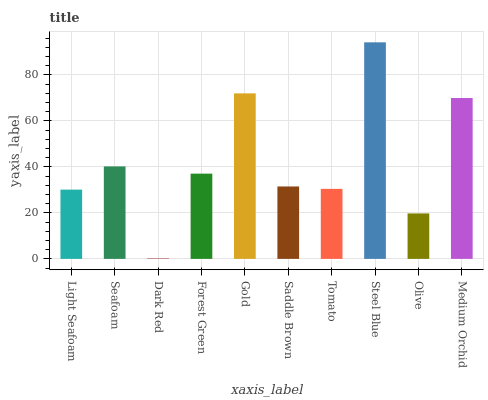Is Dark Red the minimum?
Answer yes or no. Yes. Is Steel Blue the maximum?
Answer yes or no. Yes. Is Seafoam the minimum?
Answer yes or no. No. Is Seafoam the maximum?
Answer yes or no. No. Is Seafoam greater than Light Seafoam?
Answer yes or no. Yes. Is Light Seafoam less than Seafoam?
Answer yes or no. Yes. Is Light Seafoam greater than Seafoam?
Answer yes or no. No. Is Seafoam less than Light Seafoam?
Answer yes or no. No. Is Forest Green the high median?
Answer yes or no. Yes. Is Saddle Brown the low median?
Answer yes or no. Yes. Is Steel Blue the high median?
Answer yes or no. No. Is Olive the low median?
Answer yes or no. No. 